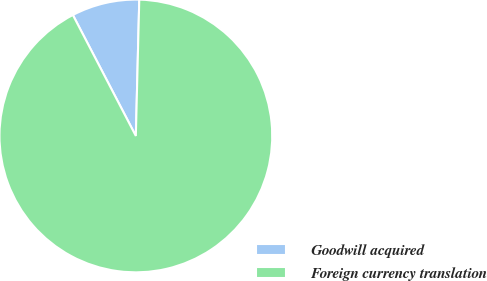Convert chart to OTSL. <chart><loc_0><loc_0><loc_500><loc_500><pie_chart><fcel>Goodwill acquired<fcel>Foreign currency translation<nl><fcel>8.04%<fcel>91.96%<nl></chart> 